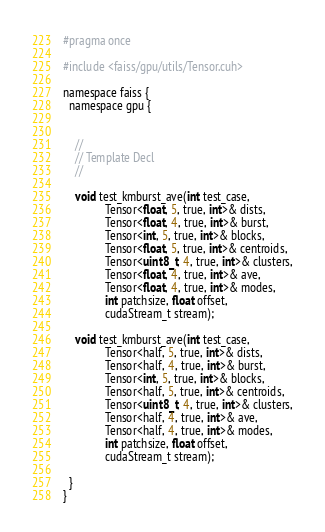Convert code to text. <code><loc_0><loc_0><loc_500><loc_500><_Cuda_>
#pragma once

#include <faiss/gpu/utils/Tensor.cuh>

namespace faiss {
  namespace gpu {


    //
    // Template Decl
    //
    
    void test_kmburst_ave(int test_case,
			  Tensor<float, 5, true, int>& dists,
			  Tensor<float, 4, true, int>& burst,
			  Tensor<int, 5, true, int>& blocks,
			  Tensor<float, 5, true, int>& centroids,
			  Tensor<uint8_t, 4, true, int>& clusters,
			  Tensor<float, 4, true, int>& ave,
			  Tensor<float, 4, true, int>& modes,
			  int patchsize, float offset,
			  cudaStream_t stream);

    void test_kmburst_ave(int test_case,
			  Tensor<half, 5, true, int>& dists,
			  Tensor<half, 4, true, int>& burst,
			  Tensor<int, 5, true, int>& blocks,
			  Tensor<half, 5, true, int>& centroids,
			  Tensor<uint8_t, 4, true, int>& clusters,
			  Tensor<half, 4, true, int>& ave,
			  Tensor<half, 4, true, int>& modes,
			  int patchsize, float offset,
			  cudaStream_t stream);

  }
}</code> 